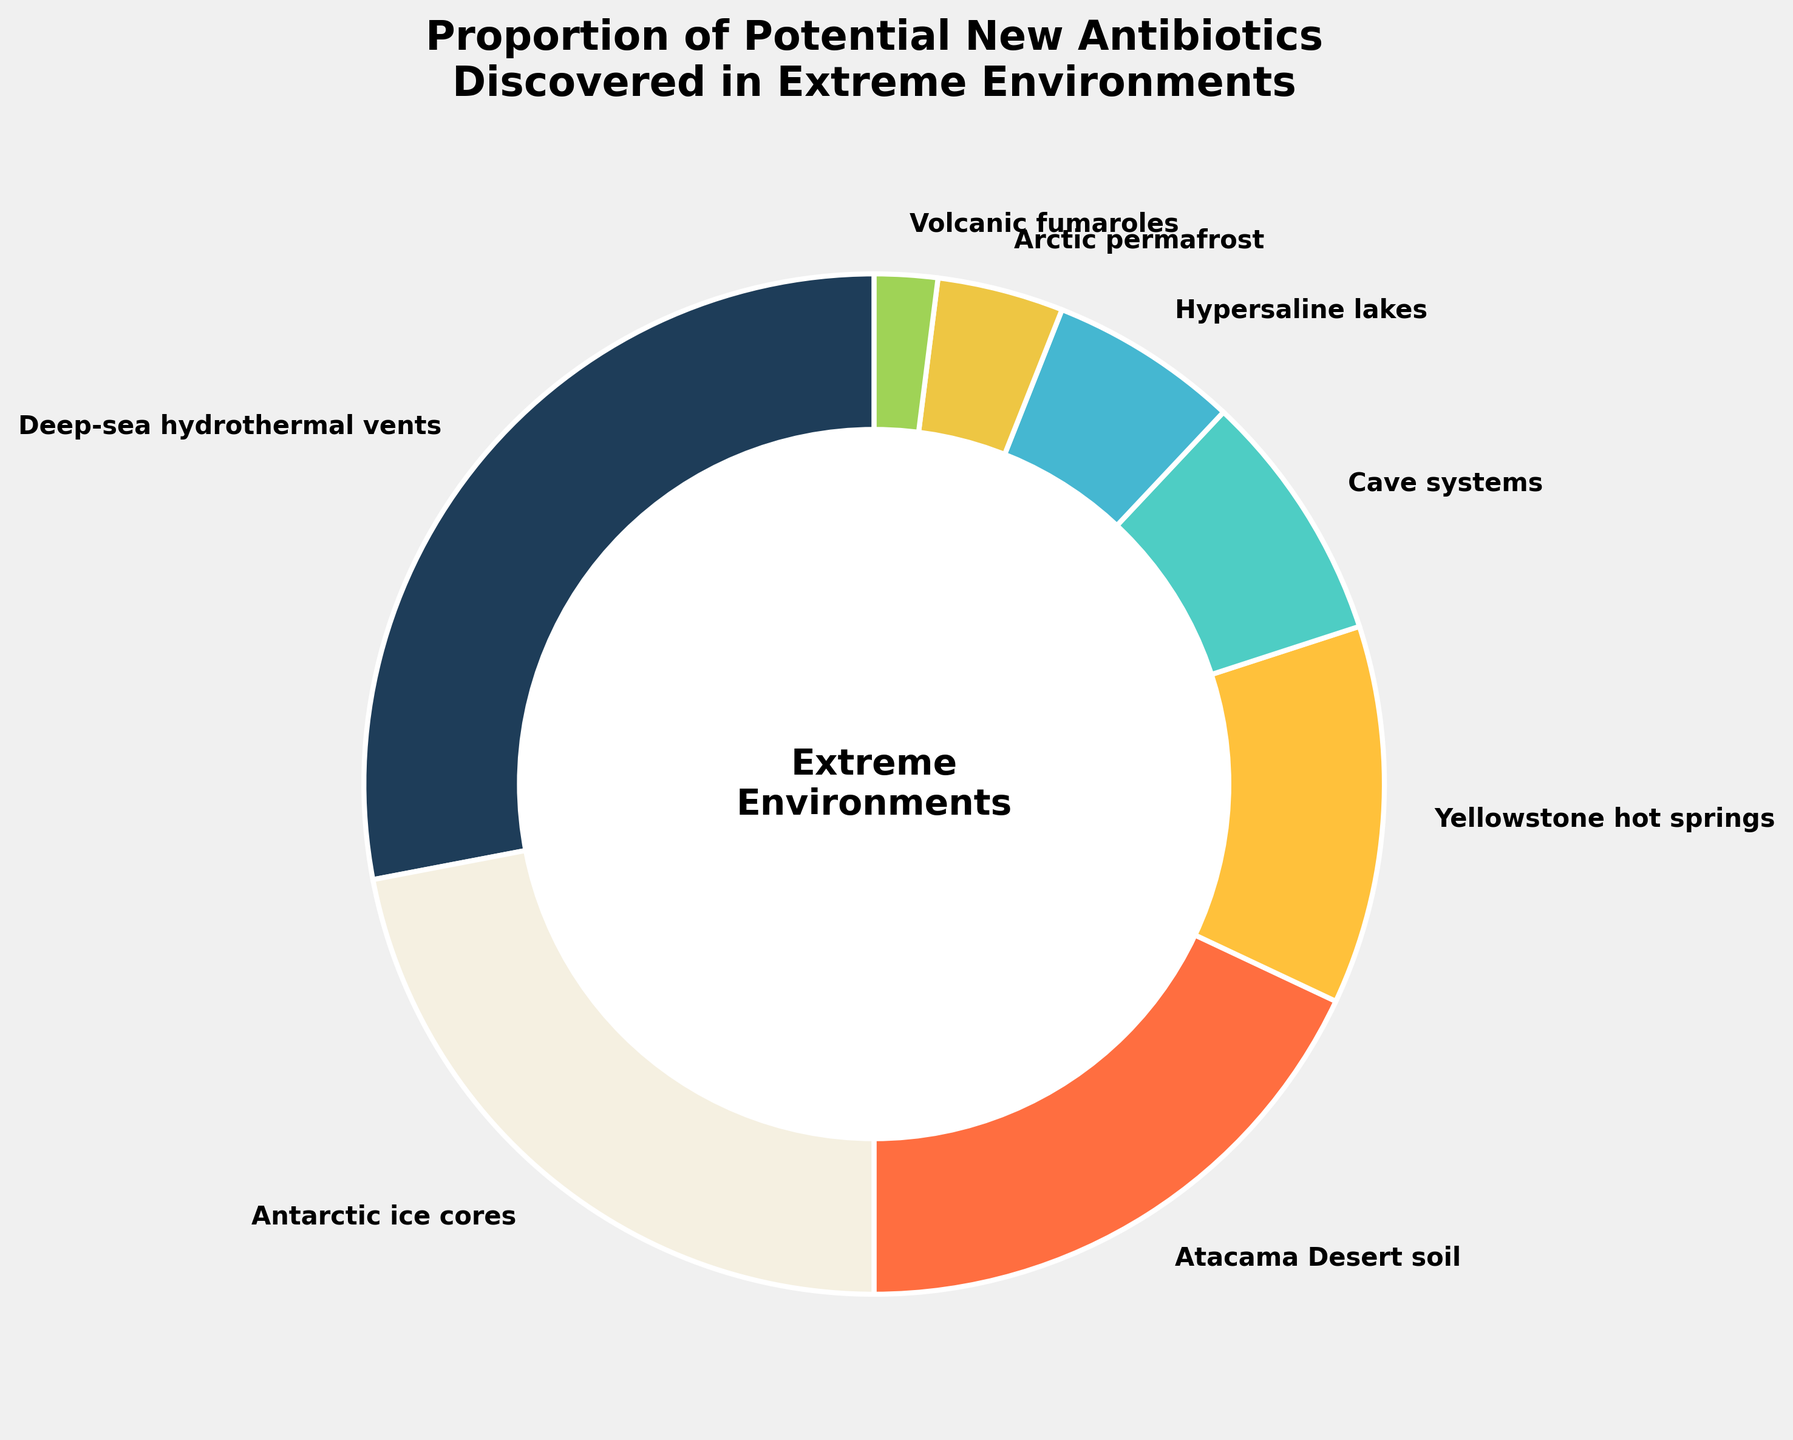What environment has the highest proportion of potential new antibiotics? The figure shows that "Deep-sea hydrothermal vents" has the highest proportion at 28%. This is clearly indicated by the largest wedge in the pie chart.
Answer: Deep-sea hydrothermal vents Which extreme environments together account for more than half of the potential new antibiotics discovered? Summing the proportions of "Deep-sea hydrothermal vents" (28%), "Antarctic ice cores" (22%), and "Atacama Desert soil" (18%) yields a total of 68%. This is more than half of the total 100%, indicating these three environments together account for more than half.
Answer: Deep-sea hydrothermal vents, Antarctic ice cores, Atacama Desert soil Compare the proportions of potential new antibiotics discovered in "Cave systems" and "Hypersaline lakes." Which environment has a higher proportion? The chart shows that "Cave systems" have a proportion of 8%, while "Hypersaline lakes" have a proportion of 6%. Therefore, "Cave systems" have a higher proportion.
Answer: Cave systems What is the combined proportion of potential new antibiotics discovered in both "Arctic permafrost" and "Volcanic fumaroles"? Adding the proportions of "Arctic permafrost" (4%) and "Volcanic fumaroles" (2%) gives a total of 6%. This is determined by summing the values shown in the figure.
Answer: 6% Which environment has the smallest proportion of potential new antibiotics discovered? The smallest wedge in the pie chart belongs to "Volcanic fumaroles," with a proportion of 2%.
Answer: Volcanic fumaroles How does the proportion of antibiotics discovered in "Yellowstone hot springs" compare to that in "Antarctic ice cores"? The proportion in "Yellowstone hot springs" is 12%, whereas in "Antarctic ice cores" it is 22%. Comparing these values shows that "Antarctic ice cores" have a higher proportion.
Answer: Antarctic ice cores Calculate the average proportion of potential new antibiotics discovered in "Atacama Desert soil," "Yellowstone hot springs," and "Cave systems." Adding the proportions of "Atacama Desert soil" (18%), "Yellowstone hot springs" (12%), and "Cave systems" (8%) gives a total of 38%. Dividing this sum by the number of environments (3) results in an average of approximately 12.7%.
Answer: 12.7% If a new environment were discovered with an equal proportion to "Hypersaline lakes," what would be the new total percentage of potential new antibiotics discovered? The current total percentage is 100%. Adding the 6% proportion of "Hypersaline lakes" to this total results in a new total of 106%. This represents the hypothetical increase if a new environment were discovered with the same proportion.
Answer: 106% Arrange the environments in descending order of their discovered proportion of potential new antibiotics. The pie chart data shows the following order: (1) Deep-sea hydrothermal vents (28%), (2) Antarctic ice cores (22%), (3) Atacama Desert soil (18%), (4) Yellowstone hot springs (12%), (5) Cave systems (8%), (6) Hypersaline lakes (6%), (7) Arctic permafrost (4%), (8) Volcanic fumaroles (2%).
Answer: Deep-sea hydrothermal vents, Antarctic ice cores, Atacama Desert soil, Yellowstone hot springs, Cave systems, Hypersaline lakes, Arctic permafrost, Volcanic fumaroles 